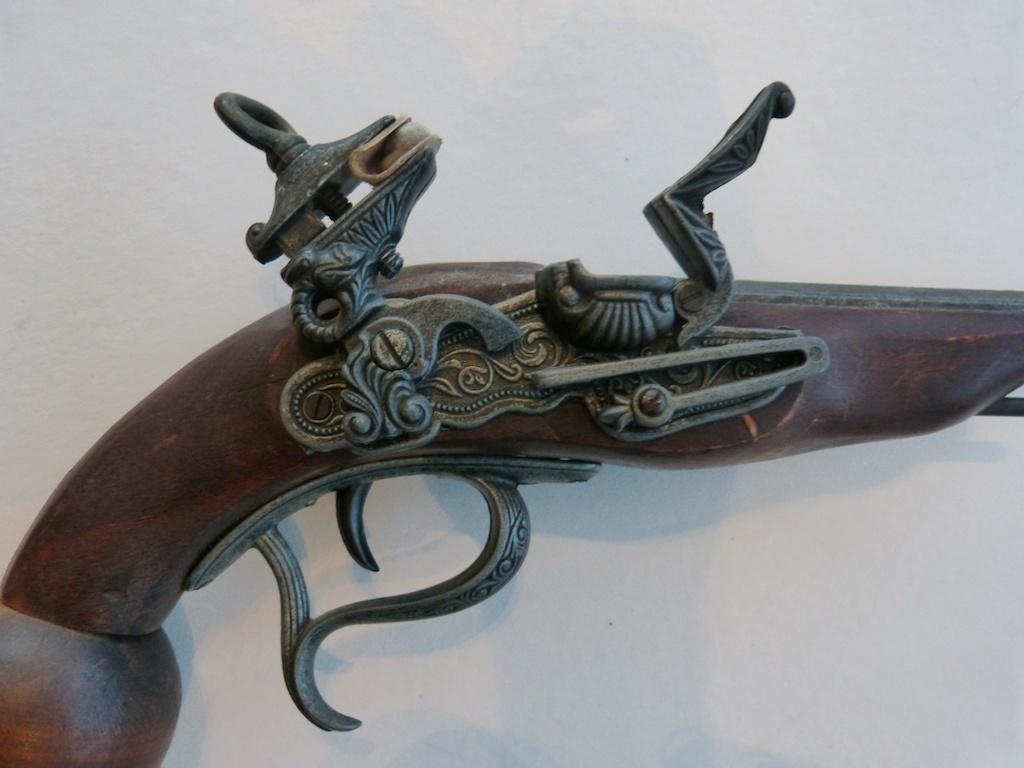How would you summarize this image in a sentence or two? In the center of the picture there is a pistol, on the pistol there is a iron sculpture. The picture has white background. 